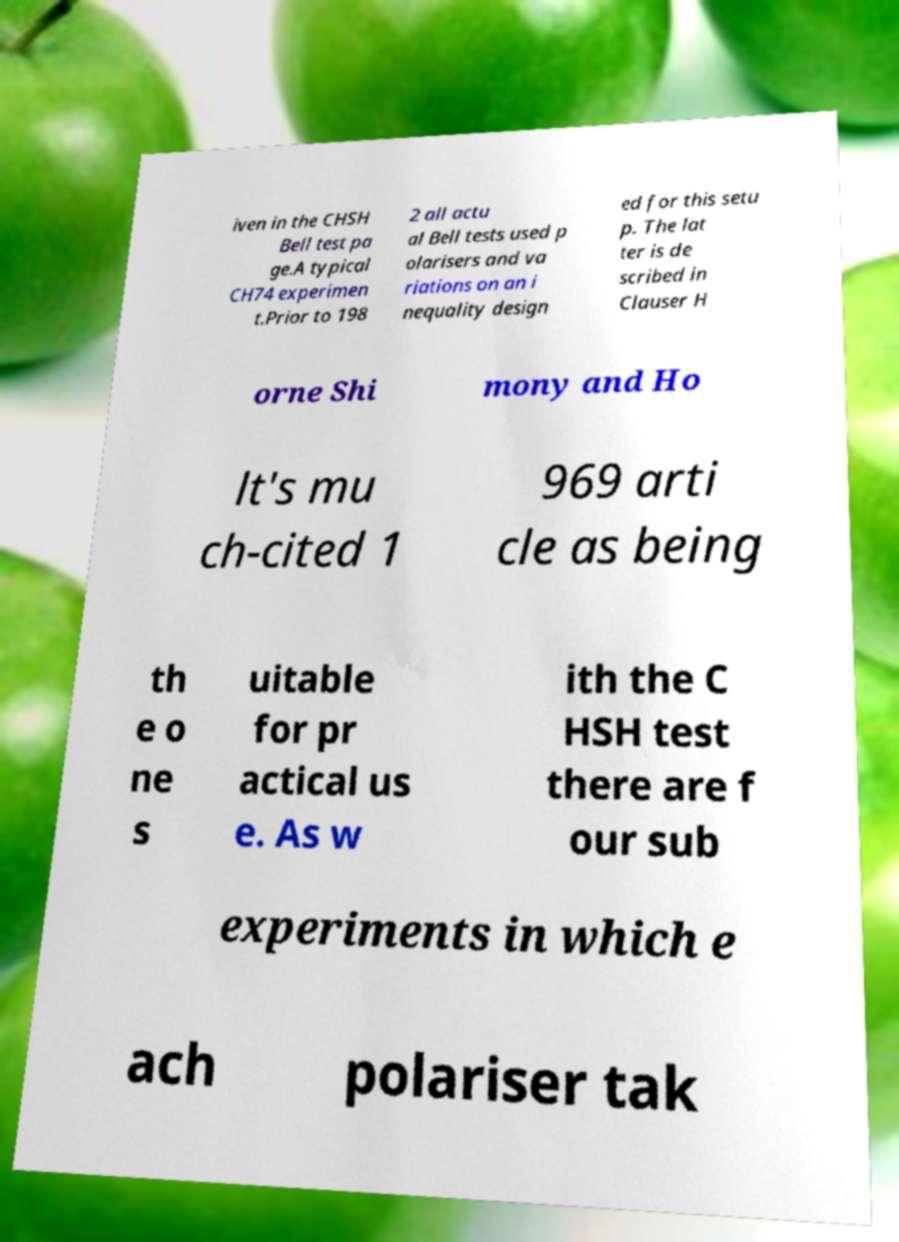I need the written content from this picture converted into text. Can you do that? iven in the CHSH Bell test pa ge.A typical CH74 experimen t.Prior to 198 2 all actu al Bell tests used p olarisers and va riations on an i nequality design ed for this setu p. The lat ter is de scribed in Clauser H orne Shi mony and Ho lt's mu ch-cited 1 969 arti cle as being th e o ne s uitable for pr actical us e. As w ith the C HSH test there are f our sub experiments in which e ach polariser tak 